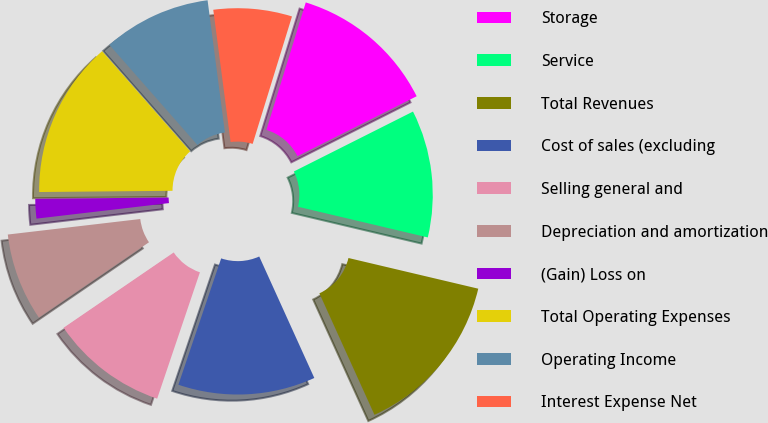<chart> <loc_0><loc_0><loc_500><loc_500><pie_chart><fcel>Storage<fcel>Service<fcel>Total Revenues<fcel>Cost of sales (excluding<fcel>Selling general and<fcel>Depreciation and amortization<fcel>(Gain) Loss on<fcel>Total Operating Expenses<fcel>Operating Income<fcel>Interest Expense Net<nl><fcel>12.82%<fcel>11.11%<fcel>14.53%<fcel>11.97%<fcel>10.26%<fcel>7.69%<fcel>1.71%<fcel>13.67%<fcel>9.4%<fcel>6.84%<nl></chart> 